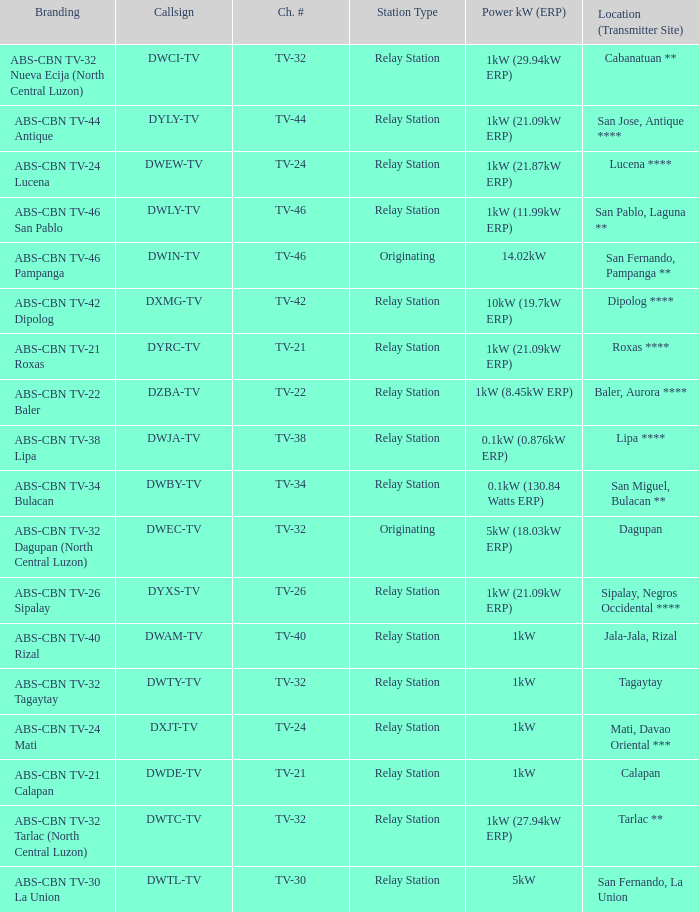What is the station type for the branding ABS-CBN TV-32 Tagaytay? Relay Station. 